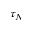Convert formula to latex. <formula><loc_0><loc_0><loc_500><loc_500>\tau _ { N }</formula> 